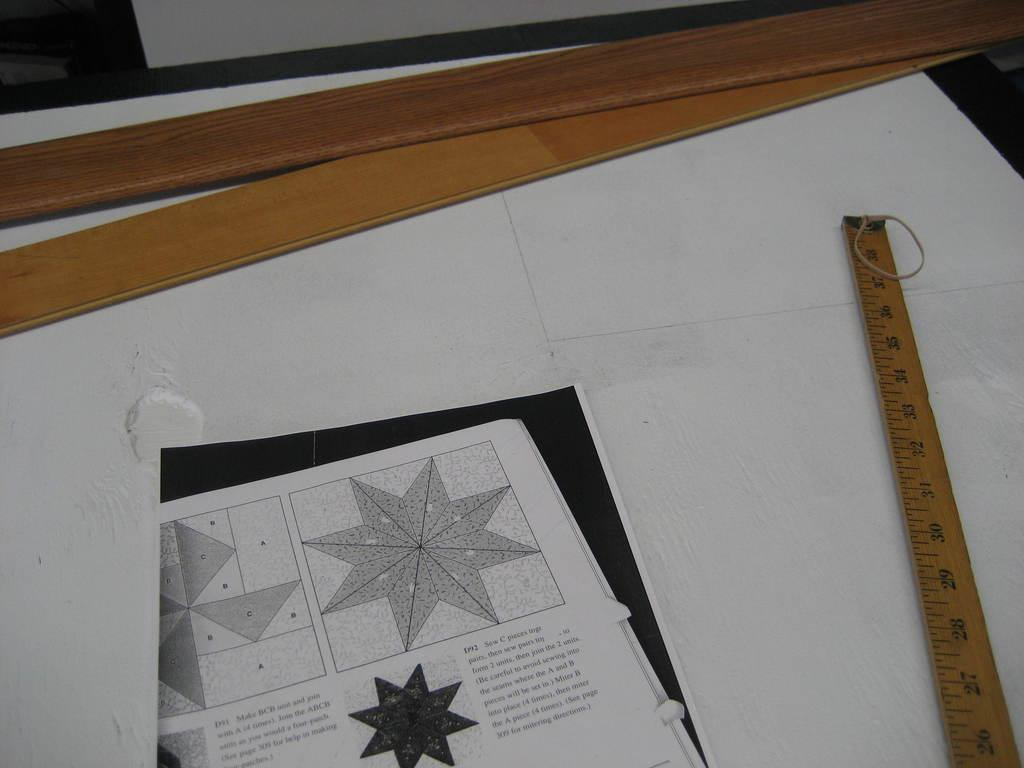Provide a one-sentence caption for the provided image. A yardstick sits next to a page of instructions with pieces labeled A, B and C. 